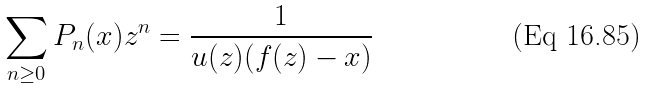Convert formula to latex. <formula><loc_0><loc_0><loc_500><loc_500>\sum _ { n \geq 0 } P _ { n } ( x ) z ^ { n } = \frac { 1 } { u ( z ) ( f ( z ) - x ) }</formula> 